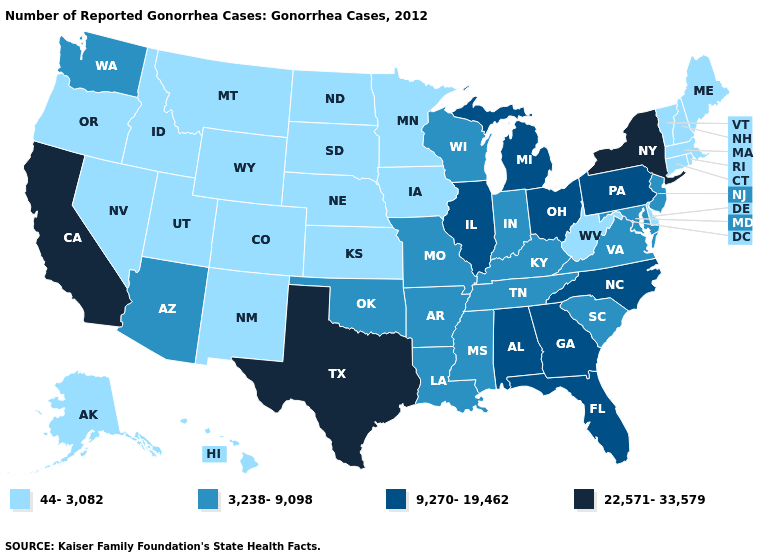What is the value of Alaska?
Answer briefly. 44-3,082. Which states hav the highest value in the Northeast?
Be succinct. New York. What is the value of Florida?
Answer briefly. 9,270-19,462. Name the states that have a value in the range 9,270-19,462?
Quick response, please. Alabama, Florida, Georgia, Illinois, Michigan, North Carolina, Ohio, Pennsylvania. Among the states that border Utah , which have the highest value?
Keep it brief. Arizona. How many symbols are there in the legend?
Short answer required. 4. Among the states that border West Virginia , which have the highest value?
Concise answer only. Ohio, Pennsylvania. Does the map have missing data?
Concise answer only. No. Does Florida have the same value as Georgia?
Short answer required. Yes. Among the states that border Arkansas , does Texas have the highest value?
Keep it brief. Yes. How many symbols are there in the legend?
Write a very short answer. 4. Name the states that have a value in the range 44-3,082?
Concise answer only. Alaska, Colorado, Connecticut, Delaware, Hawaii, Idaho, Iowa, Kansas, Maine, Massachusetts, Minnesota, Montana, Nebraska, Nevada, New Hampshire, New Mexico, North Dakota, Oregon, Rhode Island, South Dakota, Utah, Vermont, West Virginia, Wyoming. Does West Virginia have the highest value in the USA?
Quick response, please. No. Does Michigan have the highest value in the MidWest?
Keep it brief. Yes. Name the states that have a value in the range 9,270-19,462?
Give a very brief answer. Alabama, Florida, Georgia, Illinois, Michigan, North Carolina, Ohio, Pennsylvania. 